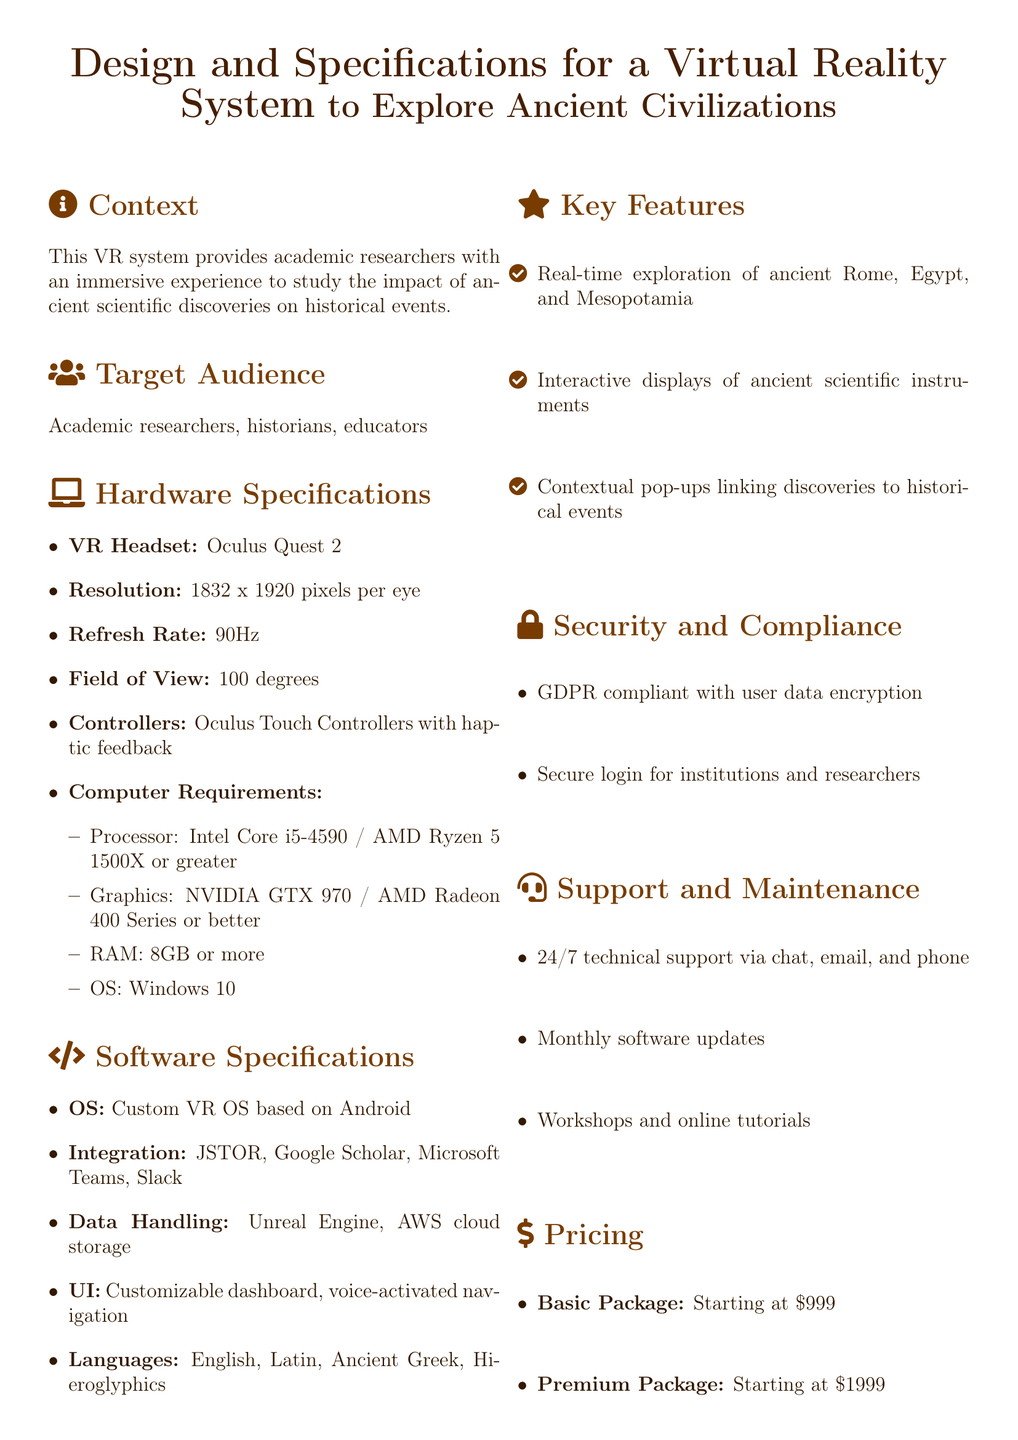What is the resolution of the VR headset? The resolution is mentioned explicitly in the hardware specifications section of the document as 1832 x 1920 pixels per eye.
Answer: 1832 x 1920 pixels per eye How many controllers are provided with the VR system? The document specifies that the VR system includes Oculus Touch Controllers with haptic feedback, which refers to a pair of controllers.
Answer: Two controllers What is the starting price of the Basic Package? The Basic Package price is clearly indicated in the pricing section as $999.
Answer: $999 Which ancient civilization can be explored in this VR system? The key features section lists ancient Rome, Egypt, and Mesopotamia, indicating the societies that can be explored.
Answer: Rome, Egypt, and Mesopotamia What are the two software integration platforms mentioned? The software specifications section mentions JSTOR and Google Scholar as part of the integration tools provided.
Answer: JSTOR and Google Scholar Why is this system significant for academic researchers? The conclusion emphasizes that this VR system aims to revolutionize the research process for academic researchers.
Answer: Revolutionize research process What type of support is available for users? The support and maintenance section details that users can access 24/7 technical support via chat, email, and phone.
Answer: 24/7 technical support What is the field of view of the VR headset? The field of view is a specific parameter listed in the hardware specifications of the document, which is 100 degrees.
Answer: 100 degrees How many languages does the system support? The software specifications mention supporting four languages: English, Latin, Ancient Greek, and Hieroglyphics.
Answer: Four languages 